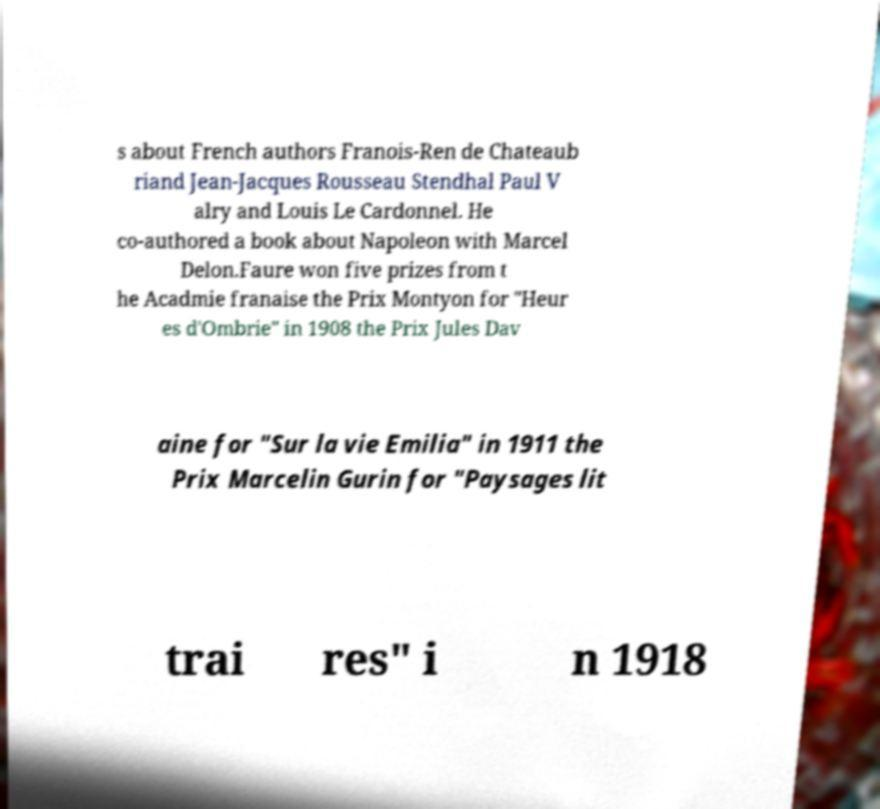Please identify and transcribe the text found in this image. s about French authors Franois-Ren de Chateaub riand Jean-Jacques Rousseau Stendhal Paul V alry and Louis Le Cardonnel. He co-authored a book about Napoleon with Marcel Delon.Faure won five prizes from t he Acadmie franaise the Prix Montyon for "Heur es d'Ombrie" in 1908 the Prix Jules Dav aine for "Sur la vie Emilia" in 1911 the Prix Marcelin Gurin for "Paysages lit trai res" i n 1918 